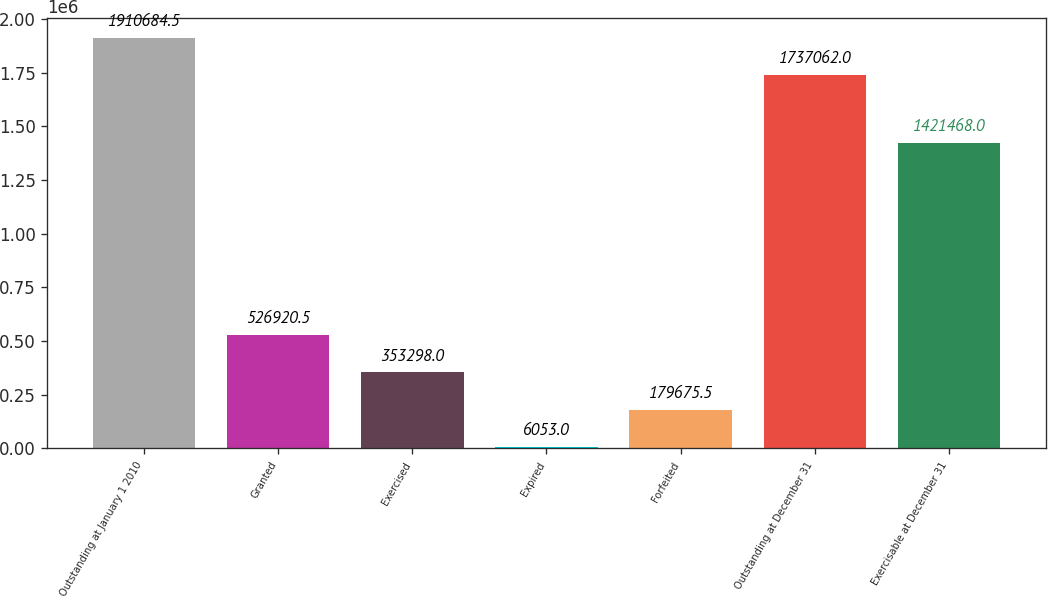Convert chart. <chart><loc_0><loc_0><loc_500><loc_500><bar_chart><fcel>Outstanding at January 1 2010<fcel>Granted<fcel>Exercised<fcel>Expired<fcel>Forfeited<fcel>Outstanding at December 31<fcel>Exercisable at December 31<nl><fcel>1.91068e+06<fcel>526920<fcel>353298<fcel>6053<fcel>179676<fcel>1.73706e+06<fcel>1.42147e+06<nl></chart> 